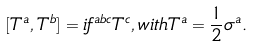<formula> <loc_0><loc_0><loc_500><loc_500>[ T ^ { a } , T ^ { b } ] = i f ^ { a b c } T ^ { c } , w i t h T ^ { a } = \frac { 1 } { 2 } \sigma ^ { a } .</formula> 